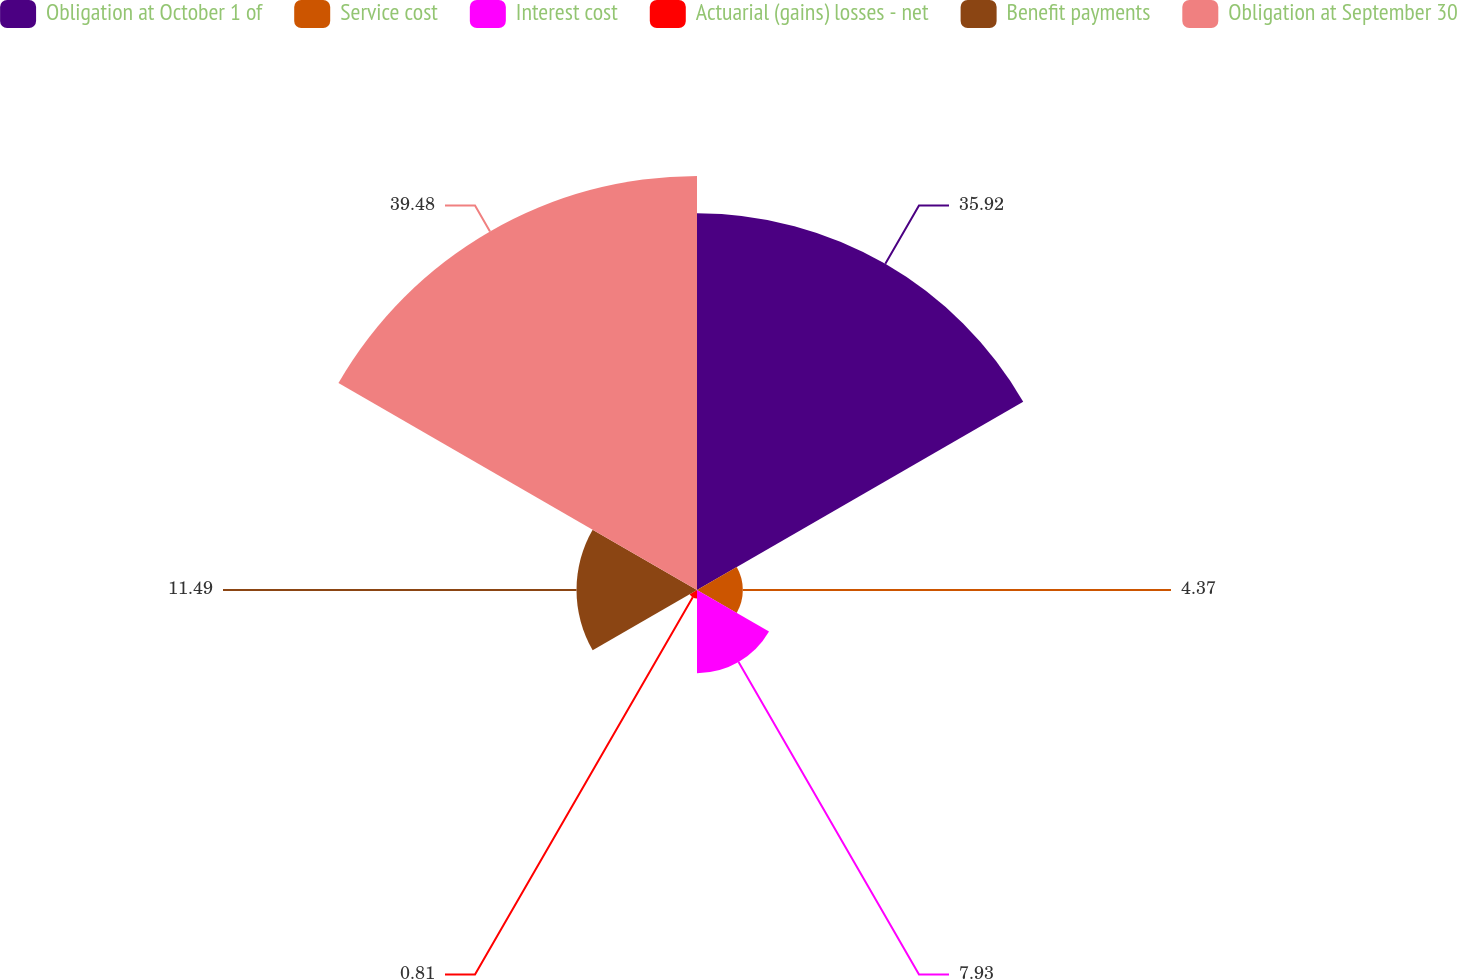Convert chart. <chart><loc_0><loc_0><loc_500><loc_500><pie_chart><fcel>Obligation at October 1 of<fcel>Service cost<fcel>Interest cost<fcel>Actuarial (gains) losses - net<fcel>Benefit payments<fcel>Obligation at September 30<nl><fcel>35.92%<fcel>4.37%<fcel>7.93%<fcel>0.81%<fcel>11.49%<fcel>39.48%<nl></chart> 